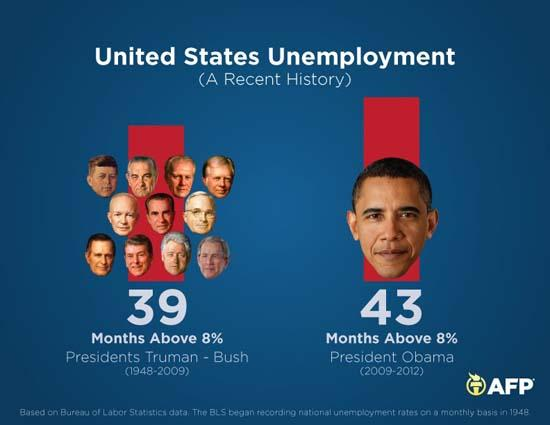Mention a couple of crucial points in this snapshot. During the period of 1948-2009, unemployment went above 8% for a total of 39 months. The presidential term of President Obama, as shown in this image, was from 2009 to 2012. During President Obama's term, unemployment went above 8% for 43 months. 